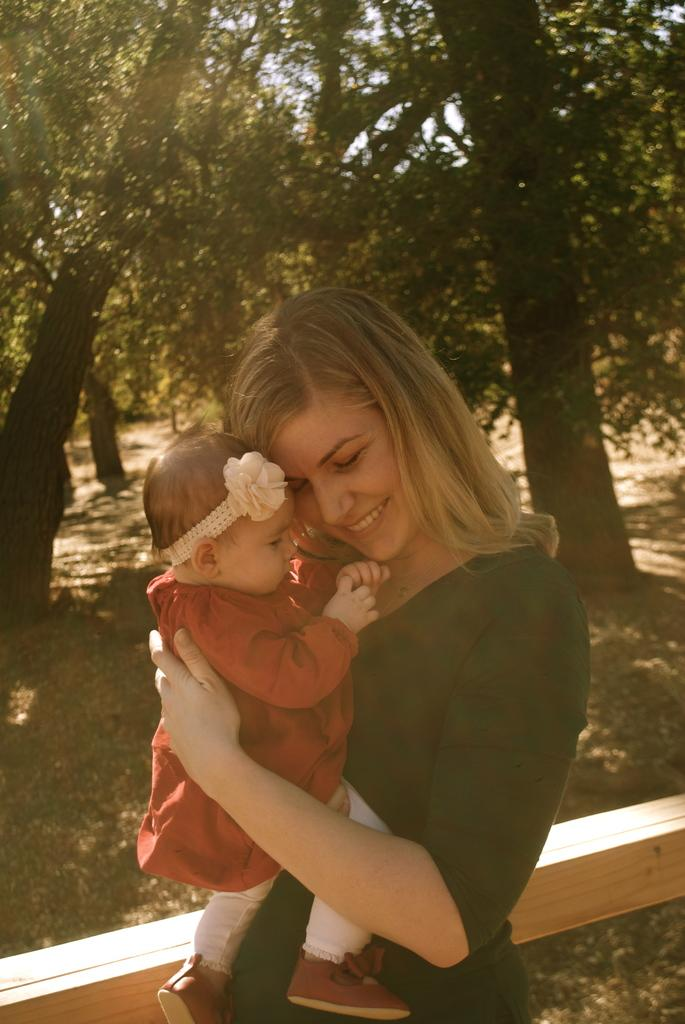What is the woman in the image doing? The woman is standing in the image and holding a baby. What is the woman wearing? The woman is wearing a black dress. What is the baby wearing? The baby is wearing a red dress. What can be seen in the background of the image? There is a tree visible in the background of the image. What type of fork is the woman using to blow on the baby's face in the image? There is no fork or blowing action present in the image; the woman is simply holding the baby. 